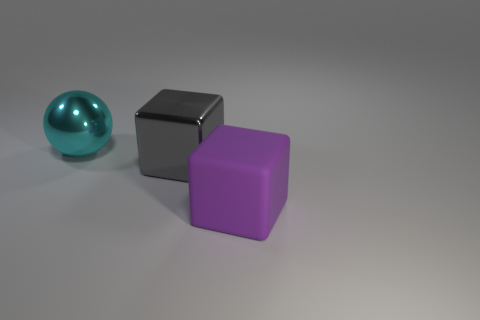Add 3 yellow rubber cubes. How many objects exist? 6 Subtract all spheres. How many objects are left? 2 Add 3 big purple matte cubes. How many big purple matte cubes exist? 4 Subtract 0 cyan blocks. How many objects are left? 3 Subtract all big purple rubber objects. Subtract all big gray objects. How many objects are left? 1 Add 2 large objects. How many large objects are left? 5 